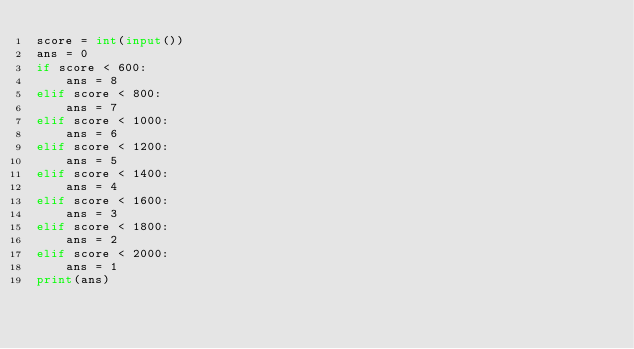<code> <loc_0><loc_0><loc_500><loc_500><_Python_>score = int(input())
ans = 0
if score < 600:
	ans = 8
elif score < 800:
  	ans = 7
elif score < 1000:
  	ans = 6
elif score < 1200:
  	ans = 5
elif score < 1400:
  	ans = 4
elif score < 1600:
  	ans = 3
elif score < 1800:
  	ans = 2
elif score < 2000:
  	ans = 1
print(ans)</code> 